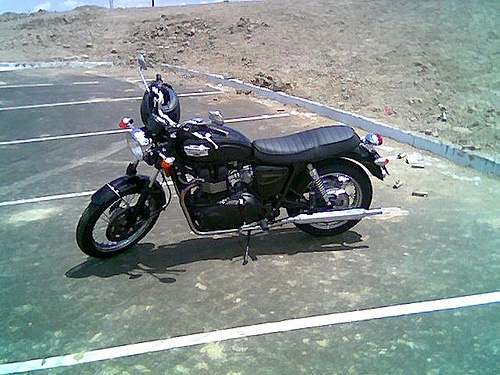Describe the objects in this image and their specific colors. I can see a motorcycle in lightblue, black, gray, darkgray, and white tones in this image. 